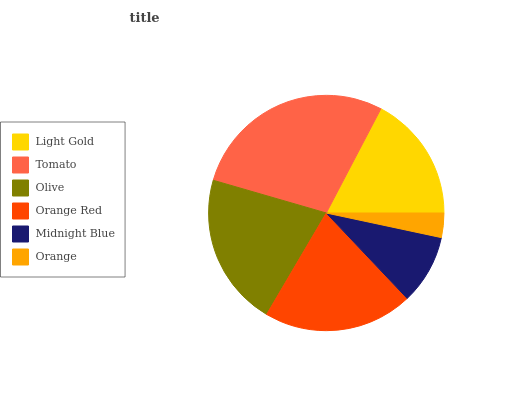Is Orange the minimum?
Answer yes or no. Yes. Is Tomato the maximum?
Answer yes or no. Yes. Is Olive the minimum?
Answer yes or no. No. Is Olive the maximum?
Answer yes or no. No. Is Tomato greater than Olive?
Answer yes or no. Yes. Is Olive less than Tomato?
Answer yes or no. Yes. Is Olive greater than Tomato?
Answer yes or no. No. Is Tomato less than Olive?
Answer yes or no. No. Is Orange Red the high median?
Answer yes or no. Yes. Is Light Gold the low median?
Answer yes or no. Yes. Is Light Gold the high median?
Answer yes or no. No. Is Midnight Blue the low median?
Answer yes or no. No. 